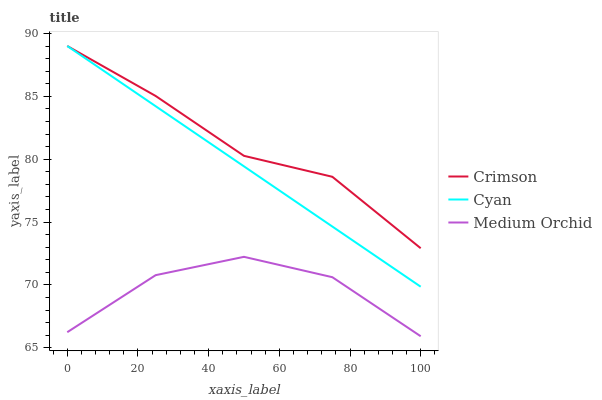Does Medium Orchid have the minimum area under the curve?
Answer yes or no. Yes. Does Crimson have the maximum area under the curve?
Answer yes or no. Yes. Does Cyan have the minimum area under the curve?
Answer yes or no. No. Does Cyan have the maximum area under the curve?
Answer yes or no. No. Is Cyan the smoothest?
Answer yes or no. Yes. Is Medium Orchid the roughest?
Answer yes or no. Yes. Is Medium Orchid the smoothest?
Answer yes or no. No. Is Cyan the roughest?
Answer yes or no. No. Does Medium Orchid have the lowest value?
Answer yes or no. Yes. Does Cyan have the lowest value?
Answer yes or no. No. Does Cyan have the highest value?
Answer yes or no. Yes. Does Medium Orchid have the highest value?
Answer yes or no. No. Is Medium Orchid less than Cyan?
Answer yes or no. Yes. Is Cyan greater than Medium Orchid?
Answer yes or no. Yes. Does Crimson intersect Cyan?
Answer yes or no. Yes. Is Crimson less than Cyan?
Answer yes or no. No. Is Crimson greater than Cyan?
Answer yes or no. No. Does Medium Orchid intersect Cyan?
Answer yes or no. No. 